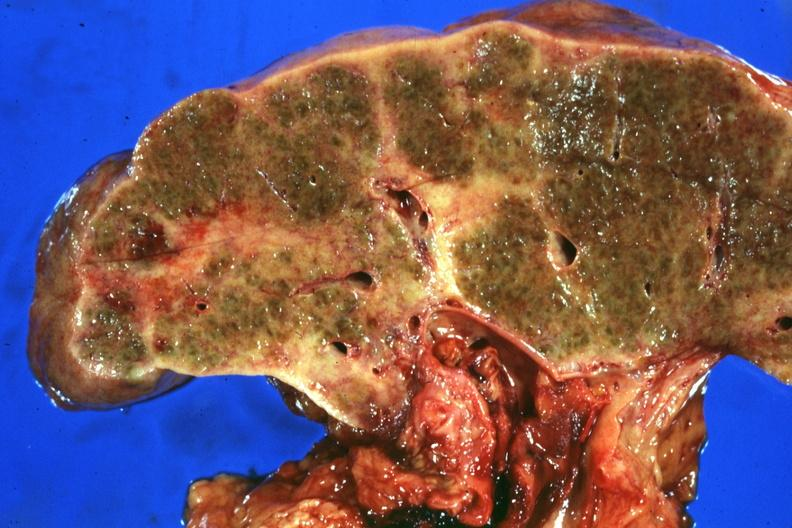s liver present?
Answer the question using a single word or phrase. Yes 